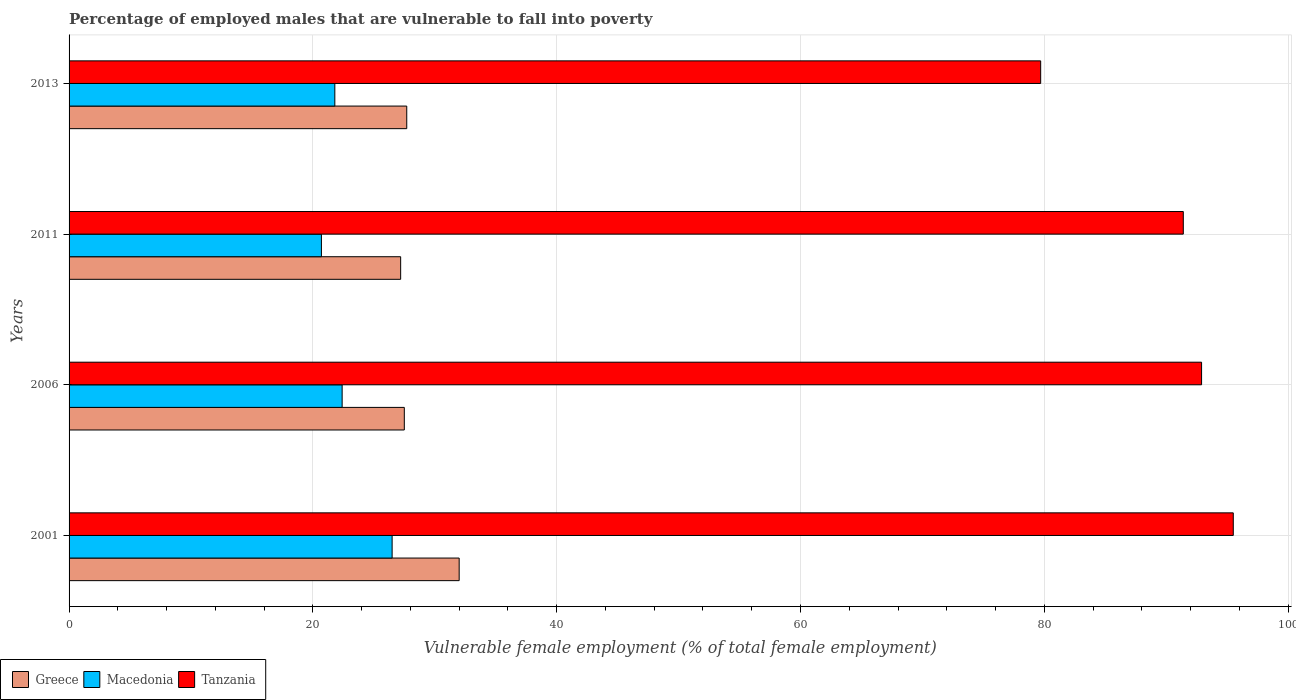How many groups of bars are there?
Give a very brief answer. 4. Are the number of bars on each tick of the Y-axis equal?
Ensure brevity in your answer.  Yes. How many bars are there on the 2nd tick from the top?
Make the answer very short. 3. How many bars are there on the 1st tick from the bottom?
Give a very brief answer. 3. What is the label of the 4th group of bars from the top?
Give a very brief answer. 2001. In how many cases, is the number of bars for a given year not equal to the number of legend labels?
Give a very brief answer. 0. What is the percentage of employed males who are vulnerable to fall into poverty in Macedonia in 2006?
Your answer should be compact. 22.4. Across all years, what is the minimum percentage of employed males who are vulnerable to fall into poverty in Macedonia?
Offer a terse response. 20.7. In which year was the percentage of employed males who are vulnerable to fall into poverty in Macedonia maximum?
Provide a succinct answer. 2001. What is the total percentage of employed males who are vulnerable to fall into poverty in Macedonia in the graph?
Provide a succinct answer. 91.4. What is the difference between the percentage of employed males who are vulnerable to fall into poverty in Macedonia in 2001 and that in 2013?
Your answer should be compact. 4.7. What is the difference between the percentage of employed males who are vulnerable to fall into poverty in Greece in 2006 and the percentage of employed males who are vulnerable to fall into poverty in Tanzania in 2013?
Give a very brief answer. -52.2. What is the average percentage of employed males who are vulnerable to fall into poverty in Macedonia per year?
Provide a succinct answer. 22.85. In the year 2011, what is the difference between the percentage of employed males who are vulnerable to fall into poverty in Tanzania and percentage of employed males who are vulnerable to fall into poverty in Greece?
Make the answer very short. 64.2. In how many years, is the percentage of employed males who are vulnerable to fall into poverty in Greece greater than 84 %?
Offer a terse response. 0. What is the ratio of the percentage of employed males who are vulnerable to fall into poverty in Tanzania in 2001 to that in 2006?
Ensure brevity in your answer.  1.03. Is the percentage of employed males who are vulnerable to fall into poverty in Tanzania in 2006 less than that in 2013?
Provide a succinct answer. No. Is the difference between the percentage of employed males who are vulnerable to fall into poverty in Tanzania in 2001 and 2013 greater than the difference between the percentage of employed males who are vulnerable to fall into poverty in Greece in 2001 and 2013?
Your answer should be compact. Yes. What is the difference between the highest and the second highest percentage of employed males who are vulnerable to fall into poverty in Macedonia?
Provide a short and direct response. 4.1. What is the difference between the highest and the lowest percentage of employed males who are vulnerable to fall into poverty in Tanzania?
Keep it short and to the point. 15.8. In how many years, is the percentage of employed males who are vulnerable to fall into poverty in Greece greater than the average percentage of employed males who are vulnerable to fall into poverty in Greece taken over all years?
Keep it short and to the point. 1. Is the sum of the percentage of employed males who are vulnerable to fall into poverty in Macedonia in 2006 and 2011 greater than the maximum percentage of employed males who are vulnerable to fall into poverty in Greece across all years?
Your answer should be very brief. Yes. What does the 3rd bar from the top in 2011 represents?
Provide a succinct answer. Greece. What does the 3rd bar from the bottom in 2013 represents?
Keep it short and to the point. Tanzania. How many bars are there?
Keep it short and to the point. 12. Are all the bars in the graph horizontal?
Your answer should be compact. Yes. How many years are there in the graph?
Your answer should be compact. 4. Are the values on the major ticks of X-axis written in scientific E-notation?
Offer a terse response. No. Where does the legend appear in the graph?
Provide a succinct answer. Bottom left. How many legend labels are there?
Ensure brevity in your answer.  3. How are the legend labels stacked?
Your answer should be very brief. Horizontal. What is the title of the graph?
Provide a succinct answer. Percentage of employed males that are vulnerable to fall into poverty. Does "Bangladesh" appear as one of the legend labels in the graph?
Give a very brief answer. No. What is the label or title of the X-axis?
Provide a short and direct response. Vulnerable female employment (% of total female employment). What is the Vulnerable female employment (% of total female employment) in Macedonia in 2001?
Give a very brief answer. 26.5. What is the Vulnerable female employment (% of total female employment) of Tanzania in 2001?
Your answer should be compact. 95.5. What is the Vulnerable female employment (% of total female employment) in Greece in 2006?
Provide a short and direct response. 27.5. What is the Vulnerable female employment (% of total female employment) of Macedonia in 2006?
Provide a short and direct response. 22.4. What is the Vulnerable female employment (% of total female employment) of Tanzania in 2006?
Give a very brief answer. 92.9. What is the Vulnerable female employment (% of total female employment) in Greece in 2011?
Keep it short and to the point. 27.2. What is the Vulnerable female employment (% of total female employment) of Macedonia in 2011?
Offer a terse response. 20.7. What is the Vulnerable female employment (% of total female employment) of Tanzania in 2011?
Keep it short and to the point. 91.4. What is the Vulnerable female employment (% of total female employment) of Greece in 2013?
Provide a short and direct response. 27.7. What is the Vulnerable female employment (% of total female employment) of Macedonia in 2013?
Ensure brevity in your answer.  21.8. What is the Vulnerable female employment (% of total female employment) of Tanzania in 2013?
Your answer should be very brief. 79.7. Across all years, what is the maximum Vulnerable female employment (% of total female employment) of Macedonia?
Offer a terse response. 26.5. Across all years, what is the maximum Vulnerable female employment (% of total female employment) of Tanzania?
Your answer should be very brief. 95.5. Across all years, what is the minimum Vulnerable female employment (% of total female employment) of Greece?
Your answer should be compact. 27.2. Across all years, what is the minimum Vulnerable female employment (% of total female employment) in Macedonia?
Your response must be concise. 20.7. Across all years, what is the minimum Vulnerable female employment (% of total female employment) in Tanzania?
Provide a short and direct response. 79.7. What is the total Vulnerable female employment (% of total female employment) in Greece in the graph?
Keep it short and to the point. 114.4. What is the total Vulnerable female employment (% of total female employment) of Macedonia in the graph?
Provide a short and direct response. 91.4. What is the total Vulnerable female employment (% of total female employment) in Tanzania in the graph?
Keep it short and to the point. 359.5. What is the difference between the Vulnerable female employment (% of total female employment) in Greece in 2001 and that in 2006?
Offer a very short reply. 4.5. What is the difference between the Vulnerable female employment (% of total female employment) in Tanzania in 2001 and that in 2006?
Offer a very short reply. 2.6. What is the difference between the Vulnerable female employment (% of total female employment) in Macedonia in 2001 and that in 2011?
Give a very brief answer. 5.8. What is the difference between the Vulnerable female employment (% of total female employment) in Greece in 2001 and that in 2013?
Offer a very short reply. 4.3. What is the difference between the Vulnerable female employment (% of total female employment) in Macedonia in 2006 and that in 2011?
Provide a succinct answer. 1.7. What is the difference between the Vulnerable female employment (% of total female employment) in Macedonia in 2006 and that in 2013?
Ensure brevity in your answer.  0.6. What is the difference between the Vulnerable female employment (% of total female employment) in Greece in 2011 and that in 2013?
Offer a very short reply. -0.5. What is the difference between the Vulnerable female employment (% of total female employment) in Tanzania in 2011 and that in 2013?
Offer a terse response. 11.7. What is the difference between the Vulnerable female employment (% of total female employment) of Greece in 2001 and the Vulnerable female employment (% of total female employment) of Tanzania in 2006?
Ensure brevity in your answer.  -60.9. What is the difference between the Vulnerable female employment (% of total female employment) of Macedonia in 2001 and the Vulnerable female employment (% of total female employment) of Tanzania in 2006?
Offer a terse response. -66.4. What is the difference between the Vulnerable female employment (% of total female employment) in Greece in 2001 and the Vulnerable female employment (% of total female employment) in Tanzania in 2011?
Offer a very short reply. -59.4. What is the difference between the Vulnerable female employment (% of total female employment) in Macedonia in 2001 and the Vulnerable female employment (% of total female employment) in Tanzania in 2011?
Your answer should be compact. -64.9. What is the difference between the Vulnerable female employment (% of total female employment) in Greece in 2001 and the Vulnerable female employment (% of total female employment) in Macedonia in 2013?
Provide a succinct answer. 10.2. What is the difference between the Vulnerable female employment (% of total female employment) in Greece in 2001 and the Vulnerable female employment (% of total female employment) in Tanzania in 2013?
Your answer should be compact. -47.7. What is the difference between the Vulnerable female employment (% of total female employment) of Macedonia in 2001 and the Vulnerable female employment (% of total female employment) of Tanzania in 2013?
Provide a short and direct response. -53.2. What is the difference between the Vulnerable female employment (% of total female employment) of Greece in 2006 and the Vulnerable female employment (% of total female employment) of Macedonia in 2011?
Keep it short and to the point. 6.8. What is the difference between the Vulnerable female employment (% of total female employment) of Greece in 2006 and the Vulnerable female employment (% of total female employment) of Tanzania in 2011?
Ensure brevity in your answer.  -63.9. What is the difference between the Vulnerable female employment (% of total female employment) of Macedonia in 2006 and the Vulnerable female employment (% of total female employment) of Tanzania in 2011?
Your answer should be compact. -69. What is the difference between the Vulnerable female employment (% of total female employment) in Greece in 2006 and the Vulnerable female employment (% of total female employment) in Macedonia in 2013?
Make the answer very short. 5.7. What is the difference between the Vulnerable female employment (% of total female employment) of Greece in 2006 and the Vulnerable female employment (% of total female employment) of Tanzania in 2013?
Your answer should be compact. -52.2. What is the difference between the Vulnerable female employment (% of total female employment) of Macedonia in 2006 and the Vulnerable female employment (% of total female employment) of Tanzania in 2013?
Give a very brief answer. -57.3. What is the difference between the Vulnerable female employment (% of total female employment) of Greece in 2011 and the Vulnerable female employment (% of total female employment) of Tanzania in 2013?
Make the answer very short. -52.5. What is the difference between the Vulnerable female employment (% of total female employment) in Macedonia in 2011 and the Vulnerable female employment (% of total female employment) in Tanzania in 2013?
Your response must be concise. -59. What is the average Vulnerable female employment (% of total female employment) of Greece per year?
Your answer should be very brief. 28.6. What is the average Vulnerable female employment (% of total female employment) of Macedonia per year?
Your answer should be very brief. 22.85. What is the average Vulnerable female employment (% of total female employment) in Tanzania per year?
Offer a terse response. 89.88. In the year 2001, what is the difference between the Vulnerable female employment (% of total female employment) in Greece and Vulnerable female employment (% of total female employment) in Tanzania?
Ensure brevity in your answer.  -63.5. In the year 2001, what is the difference between the Vulnerable female employment (% of total female employment) of Macedonia and Vulnerable female employment (% of total female employment) of Tanzania?
Your answer should be very brief. -69. In the year 2006, what is the difference between the Vulnerable female employment (% of total female employment) in Greece and Vulnerable female employment (% of total female employment) in Tanzania?
Keep it short and to the point. -65.4. In the year 2006, what is the difference between the Vulnerable female employment (% of total female employment) in Macedonia and Vulnerable female employment (% of total female employment) in Tanzania?
Provide a succinct answer. -70.5. In the year 2011, what is the difference between the Vulnerable female employment (% of total female employment) in Greece and Vulnerable female employment (% of total female employment) in Macedonia?
Provide a succinct answer. 6.5. In the year 2011, what is the difference between the Vulnerable female employment (% of total female employment) in Greece and Vulnerable female employment (% of total female employment) in Tanzania?
Offer a very short reply. -64.2. In the year 2011, what is the difference between the Vulnerable female employment (% of total female employment) in Macedonia and Vulnerable female employment (% of total female employment) in Tanzania?
Give a very brief answer. -70.7. In the year 2013, what is the difference between the Vulnerable female employment (% of total female employment) of Greece and Vulnerable female employment (% of total female employment) of Tanzania?
Ensure brevity in your answer.  -52. In the year 2013, what is the difference between the Vulnerable female employment (% of total female employment) of Macedonia and Vulnerable female employment (% of total female employment) of Tanzania?
Your answer should be very brief. -57.9. What is the ratio of the Vulnerable female employment (% of total female employment) of Greece in 2001 to that in 2006?
Your answer should be very brief. 1.16. What is the ratio of the Vulnerable female employment (% of total female employment) in Macedonia in 2001 to that in 2006?
Offer a very short reply. 1.18. What is the ratio of the Vulnerable female employment (% of total female employment) in Tanzania in 2001 to that in 2006?
Your answer should be very brief. 1.03. What is the ratio of the Vulnerable female employment (% of total female employment) in Greece in 2001 to that in 2011?
Your answer should be compact. 1.18. What is the ratio of the Vulnerable female employment (% of total female employment) of Macedonia in 2001 to that in 2011?
Give a very brief answer. 1.28. What is the ratio of the Vulnerable female employment (% of total female employment) in Tanzania in 2001 to that in 2011?
Keep it short and to the point. 1.04. What is the ratio of the Vulnerable female employment (% of total female employment) in Greece in 2001 to that in 2013?
Ensure brevity in your answer.  1.16. What is the ratio of the Vulnerable female employment (% of total female employment) of Macedonia in 2001 to that in 2013?
Give a very brief answer. 1.22. What is the ratio of the Vulnerable female employment (% of total female employment) in Tanzania in 2001 to that in 2013?
Keep it short and to the point. 1.2. What is the ratio of the Vulnerable female employment (% of total female employment) of Greece in 2006 to that in 2011?
Provide a short and direct response. 1.01. What is the ratio of the Vulnerable female employment (% of total female employment) of Macedonia in 2006 to that in 2011?
Keep it short and to the point. 1.08. What is the ratio of the Vulnerable female employment (% of total female employment) in Tanzania in 2006 to that in 2011?
Provide a succinct answer. 1.02. What is the ratio of the Vulnerable female employment (% of total female employment) in Greece in 2006 to that in 2013?
Keep it short and to the point. 0.99. What is the ratio of the Vulnerable female employment (% of total female employment) in Macedonia in 2006 to that in 2013?
Your answer should be compact. 1.03. What is the ratio of the Vulnerable female employment (% of total female employment) of Tanzania in 2006 to that in 2013?
Your answer should be very brief. 1.17. What is the ratio of the Vulnerable female employment (% of total female employment) of Greece in 2011 to that in 2013?
Ensure brevity in your answer.  0.98. What is the ratio of the Vulnerable female employment (% of total female employment) of Macedonia in 2011 to that in 2013?
Provide a succinct answer. 0.95. What is the ratio of the Vulnerable female employment (% of total female employment) of Tanzania in 2011 to that in 2013?
Provide a short and direct response. 1.15. What is the difference between the highest and the second highest Vulnerable female employment (% of total female employment) in Greece?
Keep it short and to the point. 4.3. What is the difference between the highest and the second highest Vulnerable female employment (% of total female employment) in Macedonia?
Keep it short and to the point. 4.1. What is the difference between the highest and the lowest Vulnerable female employment (% of total female employment) of Greece?
Offer a very short reply. 4.8. What is the difference between the highest and the lowest Vulnerable female employment (% of total female employment) of Macedonia?
Keep it short and to the point. 5.8. 